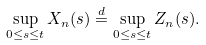Convert formula to latex. <formula><loc_0><loc_0><loc_500><loc_500>\sup _ { 0 \leq s \leq t } X _ { n } ( s ) \overset { d } { = } \sup _ { 0 \leq s \leq t } Z _ { n } ( s ) .</formula> 